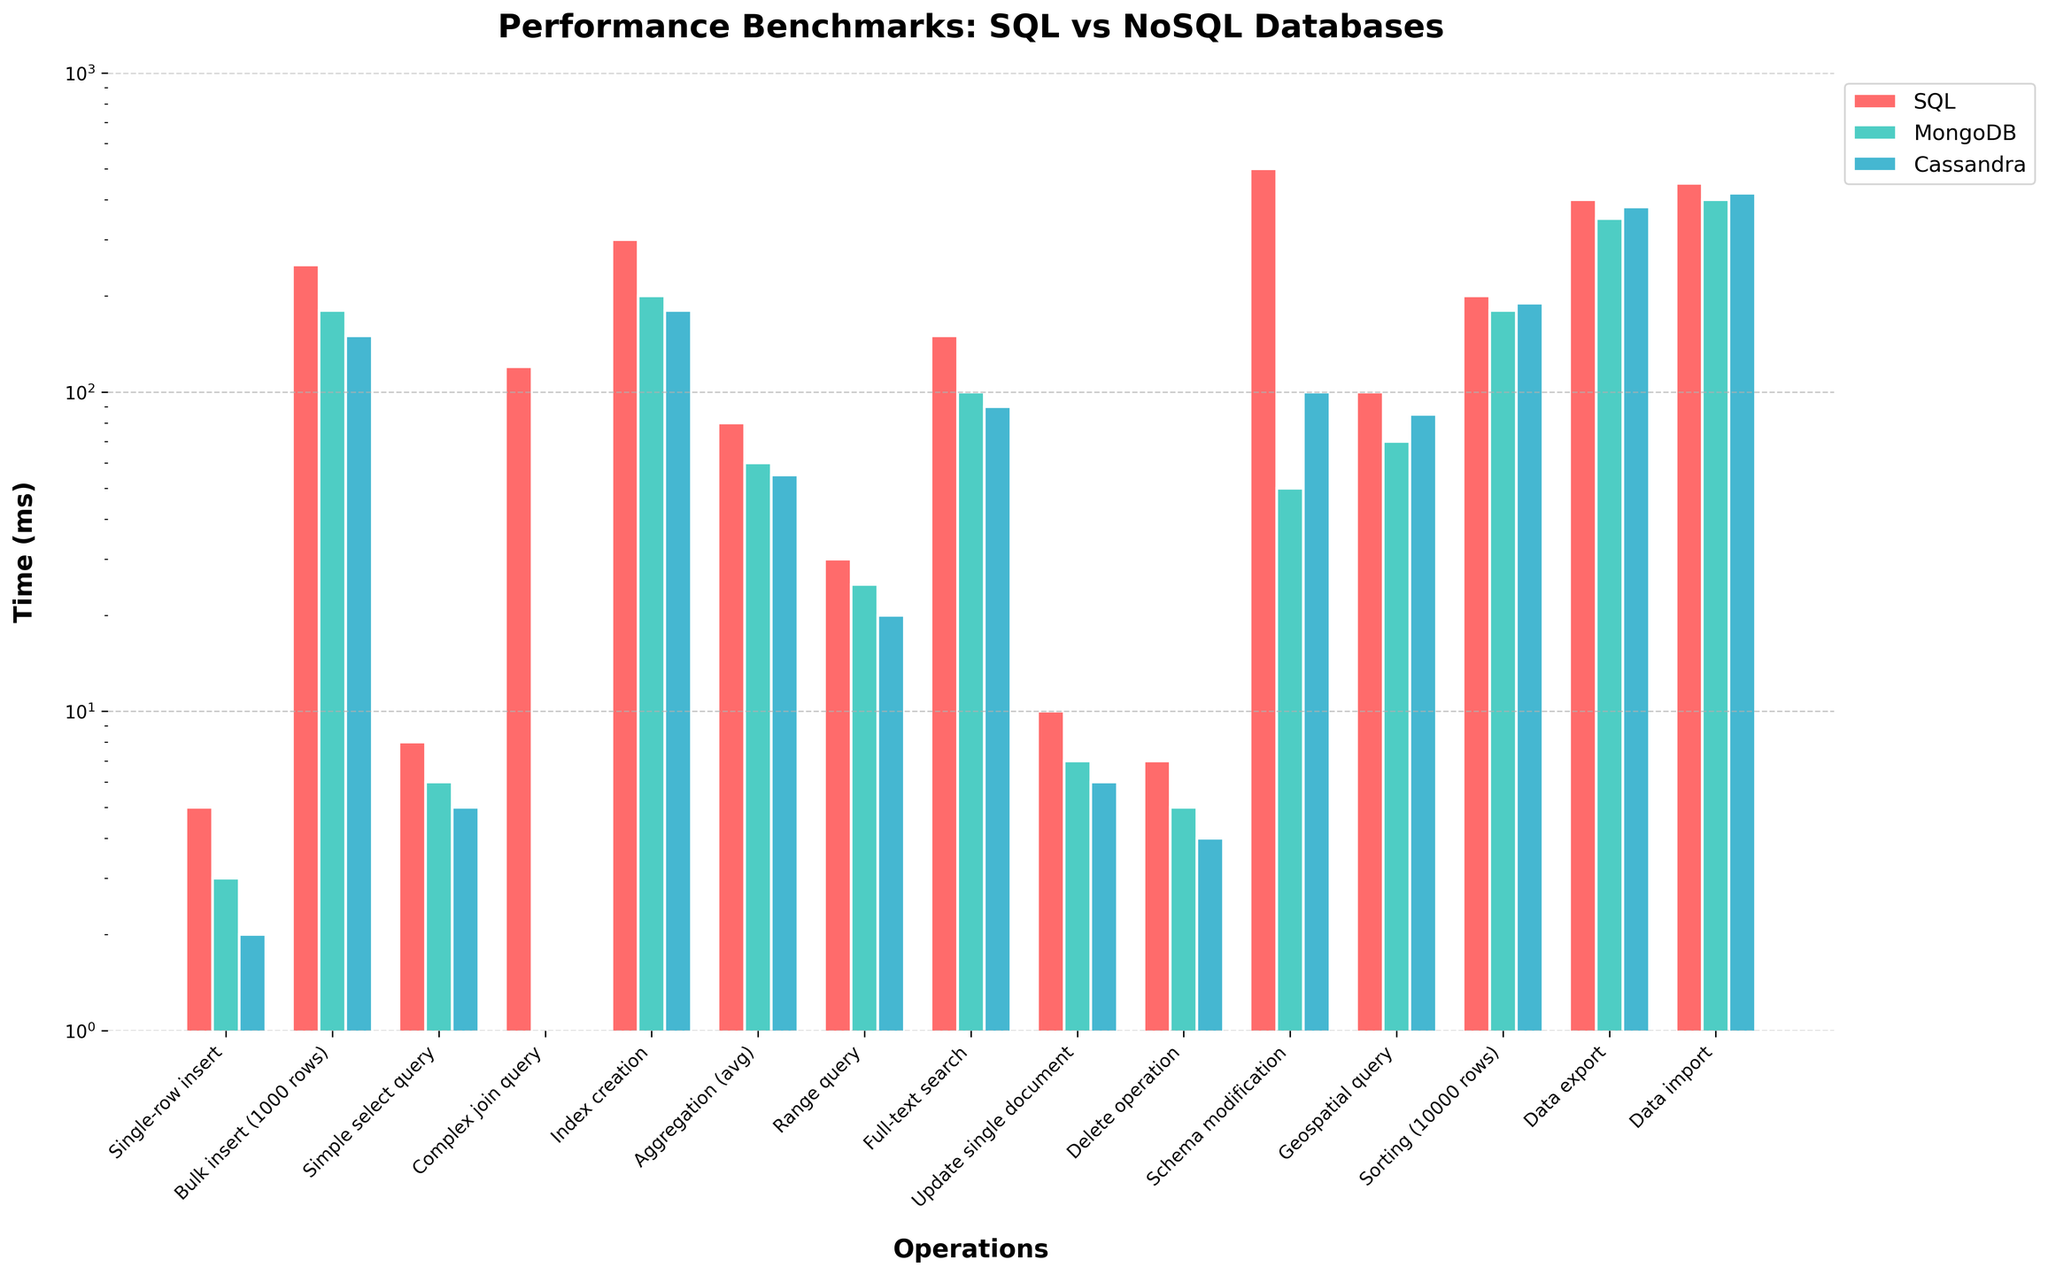Which operation has the lowest time for SQL, and how much is it? Look at the heights of the bars for SQL (red). The shortest bar represents "Single-row insert," and its value is 5 ms.
Answer: Single-row insert, 5 ms Which operation has the highest execution time for MongoDB? Look at the green bars (MongoDB). The highest bar corresponds to "Data import" with a value of 400 ms.
Answer: Data import, 400 ms By how much does the "Complex join query" time for SQL exceed the "Aggregation (avg)" time for SQL? The time for the "Complex join query" for SQL is 120 ms, and for the "Aggregation (avg)" it is 80 ms. The difference is 120 - 80 = 40 ms.
Answer: 40 ms Which database performs better in "Range query"? Compare the three bars for "Range query." The Cassandra bar (blue) is the shortest, indicating it has the lowest time of 20 ms.
Answer: Cassandra Which operation shows the greatest discrepancy between SQL and Cassandra times? Find the difference between SQL and Cassandra times for each operation. The greatest discrepancy is for "Schema modification" with SQL at 500 ms and Cassandra at 100 ms, a difference of 400 ms.
Answer: Schema modification For the "Full-text search" operation, what is the average time considering all databases? The times for "Full-text search" are SQL: 150 ms, MongoDB: 100 ms, Cassandra: 90 ms. The average is (150 + 100 + 90) / 3 = 340 / 3 ≈ 113.33 ms.
Answer: ≈113.33 ms How many operations does Cassandra perform faster than SQL? Compare the heights of the bars for each operation. Cassandra performs faster than SQL in 11 operations: Single-row insert, Bulk insert, Simple select query, Index creation, Aggregation (avg), Range query, Full-text search, Update single document, Delete operation, Schema modification, Data export.
Answer: 11 What's the ratio of execution times for SQL and MongoDB in the "Index creation" operation? The times for "Index creation" are SQL: 300 ms and MongoDB: 200 ms. The ratio is 300 / 200 = 1.5.
Answer: 1.5 Which database is fastest for the "Update single document" operation, and by how much does it exceed the slowest one? The times for "Update single document" are SQL: 10 ms, MongoDB: 7 ms, Cassandra: 6 ms. Cassandra is the fastest at 6 ms and SQL is the slowest at 10 ms. The difference is 10 - 6 = 4 ms.
Answer: Cassandra, 4 ms Compare the performance of MongoDB and Cassandra in executing "Sorting (10000 rows)" and state which one is faster. Examine the bars for "Sorting (10000 rows)." MongoDB shows a time of 180 ms, while Cassandra shows 190 ms. Thus, MongoDB is faster by 10 ms.
Answer: MongoDB 